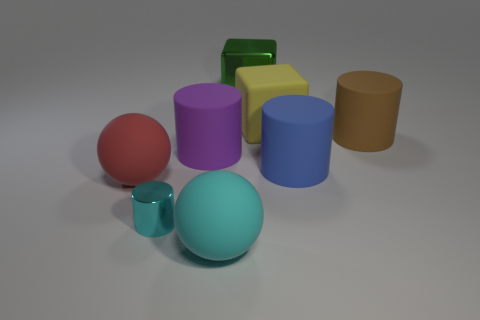Are there any other things that are the same size as the cyan cylinder?
Offer a very short reply. No. What number of red things are either large shiny cylinders or rubber balls?
Make the answer very short. 1. Do the big rubber cylinder that is left of the rubber block and the small metal object have the same color?
Keep it short and to the point. No. What size is the shiny object that is behind the rubber object that is behind the big brown rubber cylinder?
Your answer should be very brief. Large. What material is the blue cylinder that is the same size as the brown cylinder?
Offer a terse response. Rubber. How many other objects are the same size as the purple matte cylinder?
Make the answer very short. 6. How many cylinders are either tiny rubber things or shiny objects?
Give a very brief answer. 1. Is there any other thing that is made of the same material as the large red sphere?
Offer a terse response. Yes. What is the large sphere right of the rubber ball that is on the left side of the large thing in front of the tiny cyan metal cylinder made of?
Keep it short and to the point. Rubber. There is a big sphere that is the same color as the tiny cylinder; what material is it?
Your answer should be compact. Rubber. 